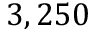Convert formula to latex. <formula><loc_0><loc_0><loc_500><loc_500>3 , 2 5 0</formula> 